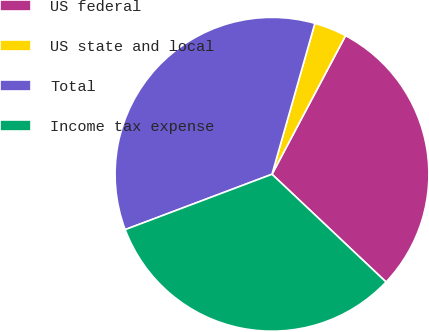<chart> <loc_0><loc_0><loc_500><loc_500><pie_chart><fcel>US federal<fcel>US state and local<fcel>Total<fcel>Income tax expense<nl><fcel>29.28%<fcel>3.36%<fcel>35.14%<fcel>32.21%<nl></chart> 